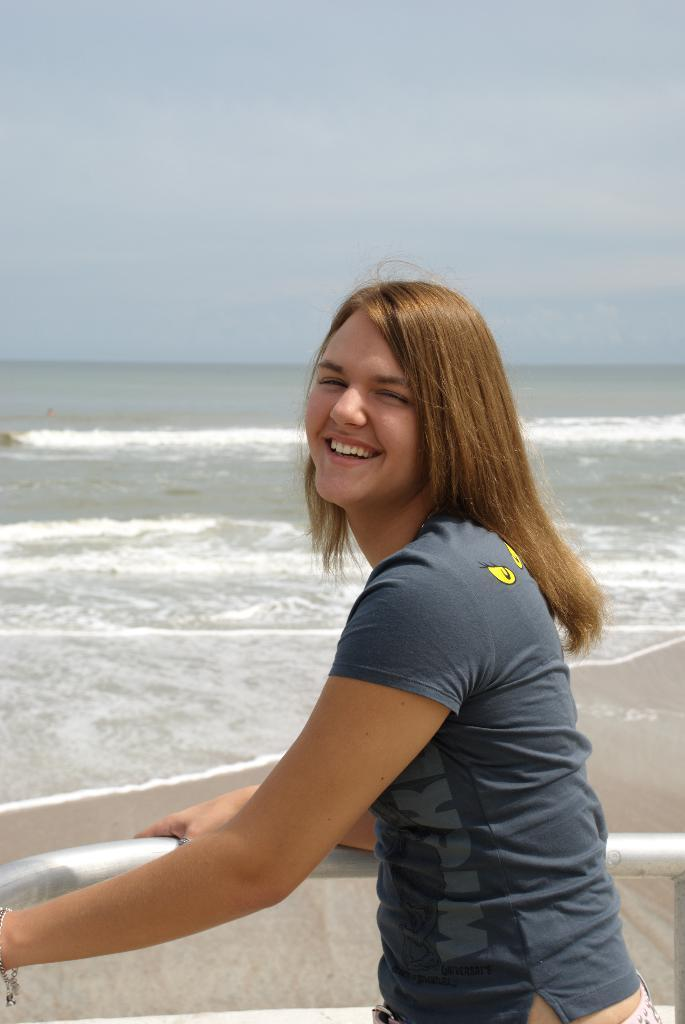Who is present in the image? There is a lady standing in the image. What is at the bottom of the image? There is a railing at the bottom of the image. What can be seen in the background of the image? There is water visible in the background of the image. What is visible at the top of the image? The sky is visible at the top of the image. How many hens are sitting on the wall in the image? There are no hens or walls present in the image. 